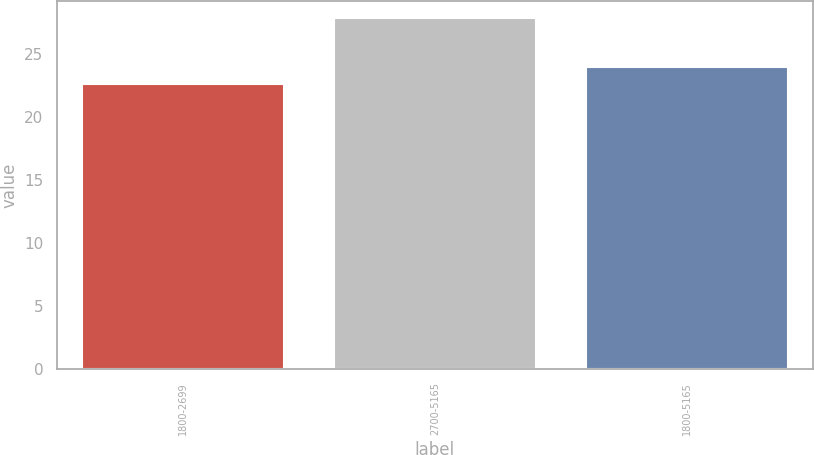Convert chart. <chart><loc_0><loc_0><loc_500><loc_500><bar_chart><fcel>1800-2699<fcel>2700-5165<fcel>1800-5165<nl><fcel>22.63<fcel>27.84<fcel>23.99<nl></chart> 